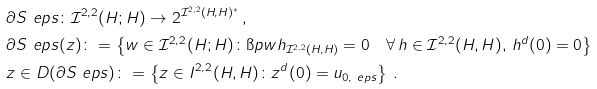<formula> <loc_0><loc_0><loc_500><loc_500>& \partial S _ { \ } e p s \colon \mathcal { I } ^ { 2 , 2 } ( H ; H ) \to 2 ^ { \mathcal { I } ^ { 2 , 2 } ( H , H ) ^ { * } } \, , \\ & \partial S _ { \ } e p s ( z ) \colon = \left \{ w \in \mathcal { I } ^ { 2 , 2 } ( H ; H ) \colon \i p { w } { h } _ { \mathcal { I } ^ { 2 , 2 } ( H , H ) } = 0 \quad \forall \, h \in \mathcal { I } ^ { 2 , 2 } ( H , H ) , \, h ^ { d } ( 0 ) = 0 \right \} \\ & z \in D ( \partial S _ { \ } e p s ) \colon = \left \{ z \in I ^ { 2 , 2 } ( H , H ) \colon z ^ { d } ( 0 ) = u _ { 0 , \ e p s } \right \} \, .</formula> 